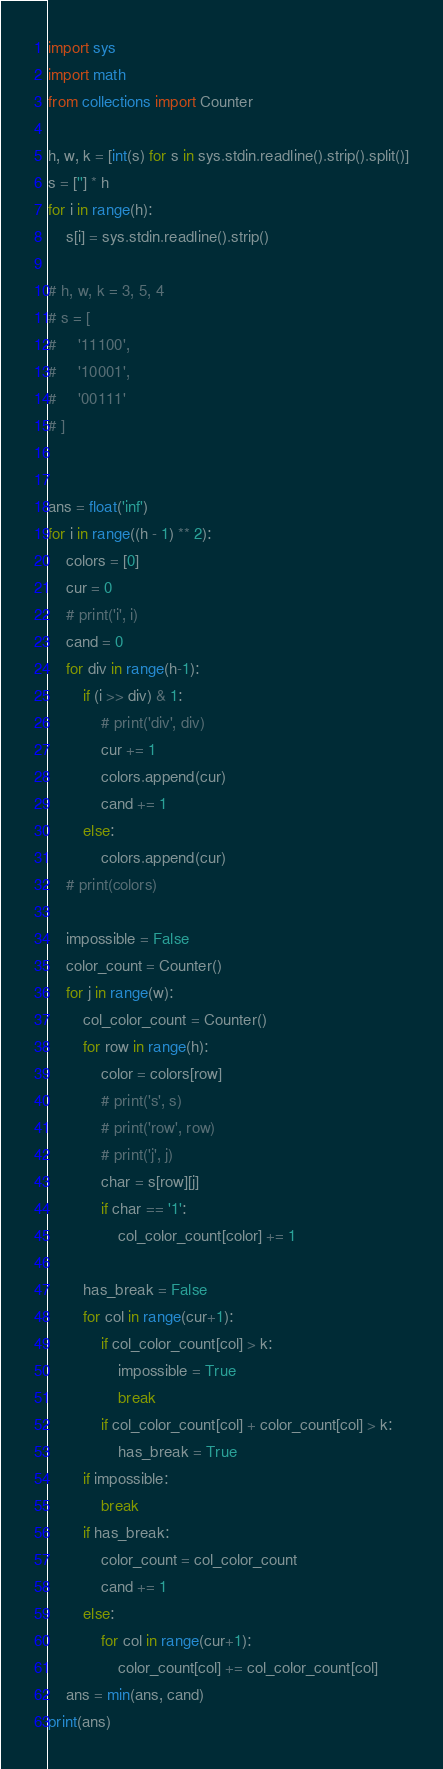<code> <loc_0><loc_0><loc_500><loc_500><_Python_>import sys
import math
from collections import Counter

h, w, k = [int(s) for s in sys.stdin.readline().strip().split()]
s = [''] * h
for i in range(h):
    s[i] = sys.stdin.readline().strip()

# h, w, k = 3, 5, 4
# s = [
#     '11100',
#     '10001',
#     '00111'
# ]


ans = float('inf')
for i in range((h - 1) ** 2):
    colors = [0]
    cur = 0
    # print('i', i)
    cand = 0
    for div in range(h-1):
        if (i >> div) & 1:
            # print('div', div)
            cur += 1
            colors.append(cur)
            cand += 1
        else:
            colors.append(cur)
    # print(colors)

    impossible = False
    color_count = Counter()
    for j in range(w):
        col_color_count = Counter()
        for row in range(h):
            color = colors[row]
            # print('s', s)
            # print('row', row)
            # print('j', j)
            char = s[row][j]
            if char == '1':
                col_color_count[color] += 1

        has_break = False
        for col in range(cur+1):
            if col_color_count[col] > k:
                impossible = True
                break
            if col_color_count[col] + color_count[col] > k:
                has_break = True
        if impossible:
            break
        if has_break:
            color_count = col_color_count
            cand += 1
        else:
            for col in range(cur+1):
                color_count[col] += col_color_count[col]
    ans = min(ans, cand)
print(ans)
</code> 